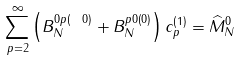<formula> <loc_0><loc_0><loc_500><loc_500>\sum _ { p = 2 } ^ { \infty } \left ( B _ { N } ^ { 0 p \left ( \ 0 \right ) } + B _ { N } ^ { p 0 \left ( 0 \right ) } \right ) c _ { p } ^ { \left ( 1 \right ) } = \widehat { M } _ { N } ^ { 0 }</formula> 